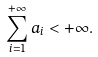<formula> <loc_0><loc_0><loc_500><loc_500>\sum _ { i = 1 } ^ { + \infty } a _ { i } < + \infty .</formula> 